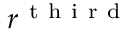<formula> <loc_0><loc_0><loc_500><loc_500>r ^ { t h i r d }</formula> 